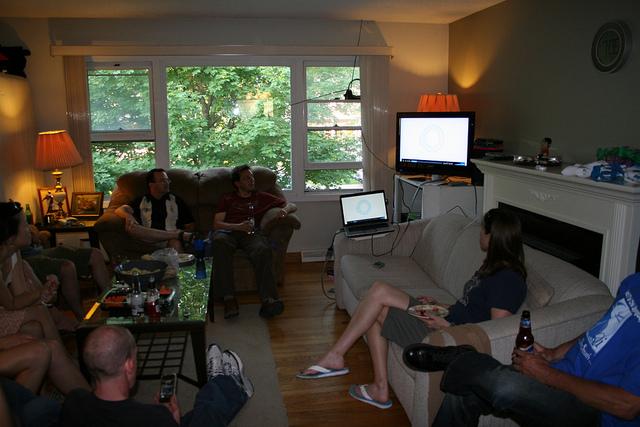Are the people inside or outside?
Short answer required. Inside. What is the man playing?
Write a very short answer. Games. How many people are watching TV?
Concise answer only. 8. Is this a party?
Quick response, please. Yes. 